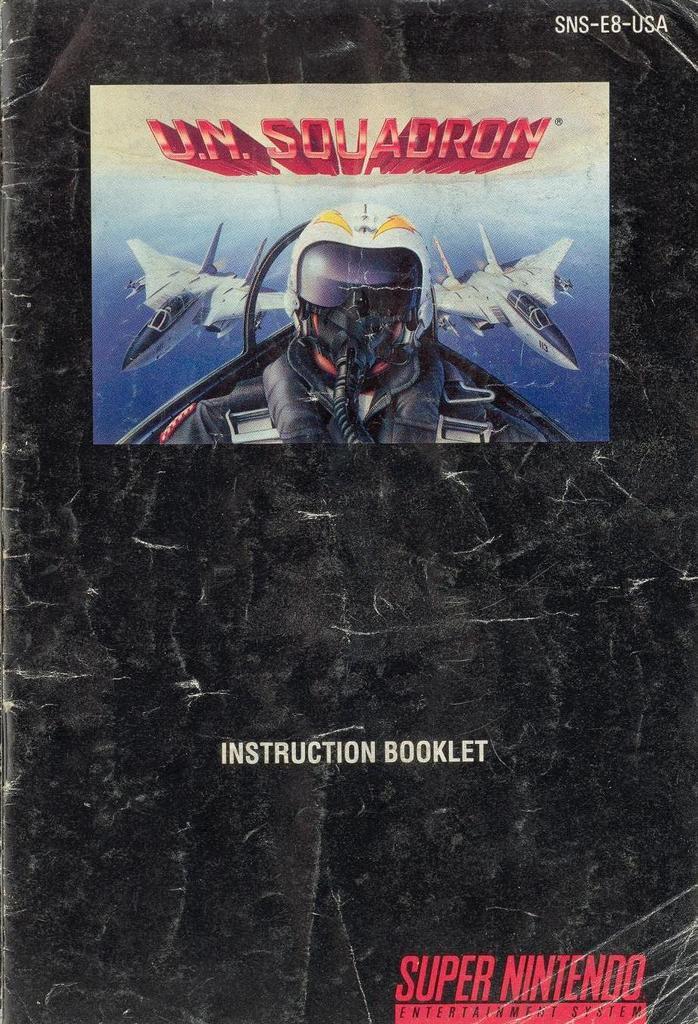What game system is this game for?
Make the answer very short. Super nintendo. Is this an instruction booklet?
Your answer should be very brief. Yes. 